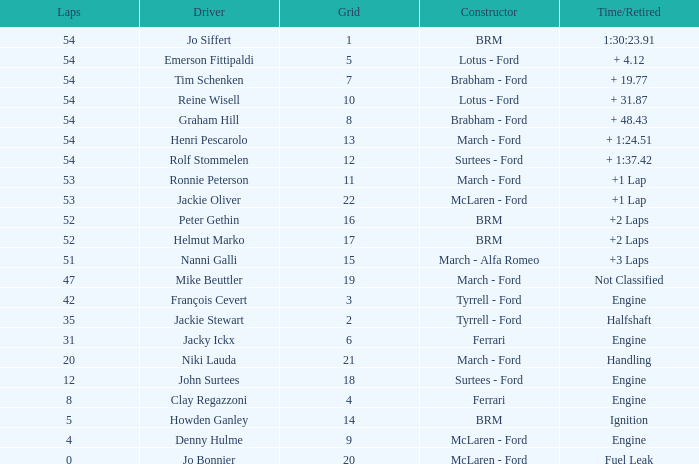What is the low grid that has brm and over 54 laps? None. 